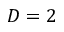Convert formula to latex. <formula><loc_0><loc_0><loc_500><loc_500>D = 2</formula> 